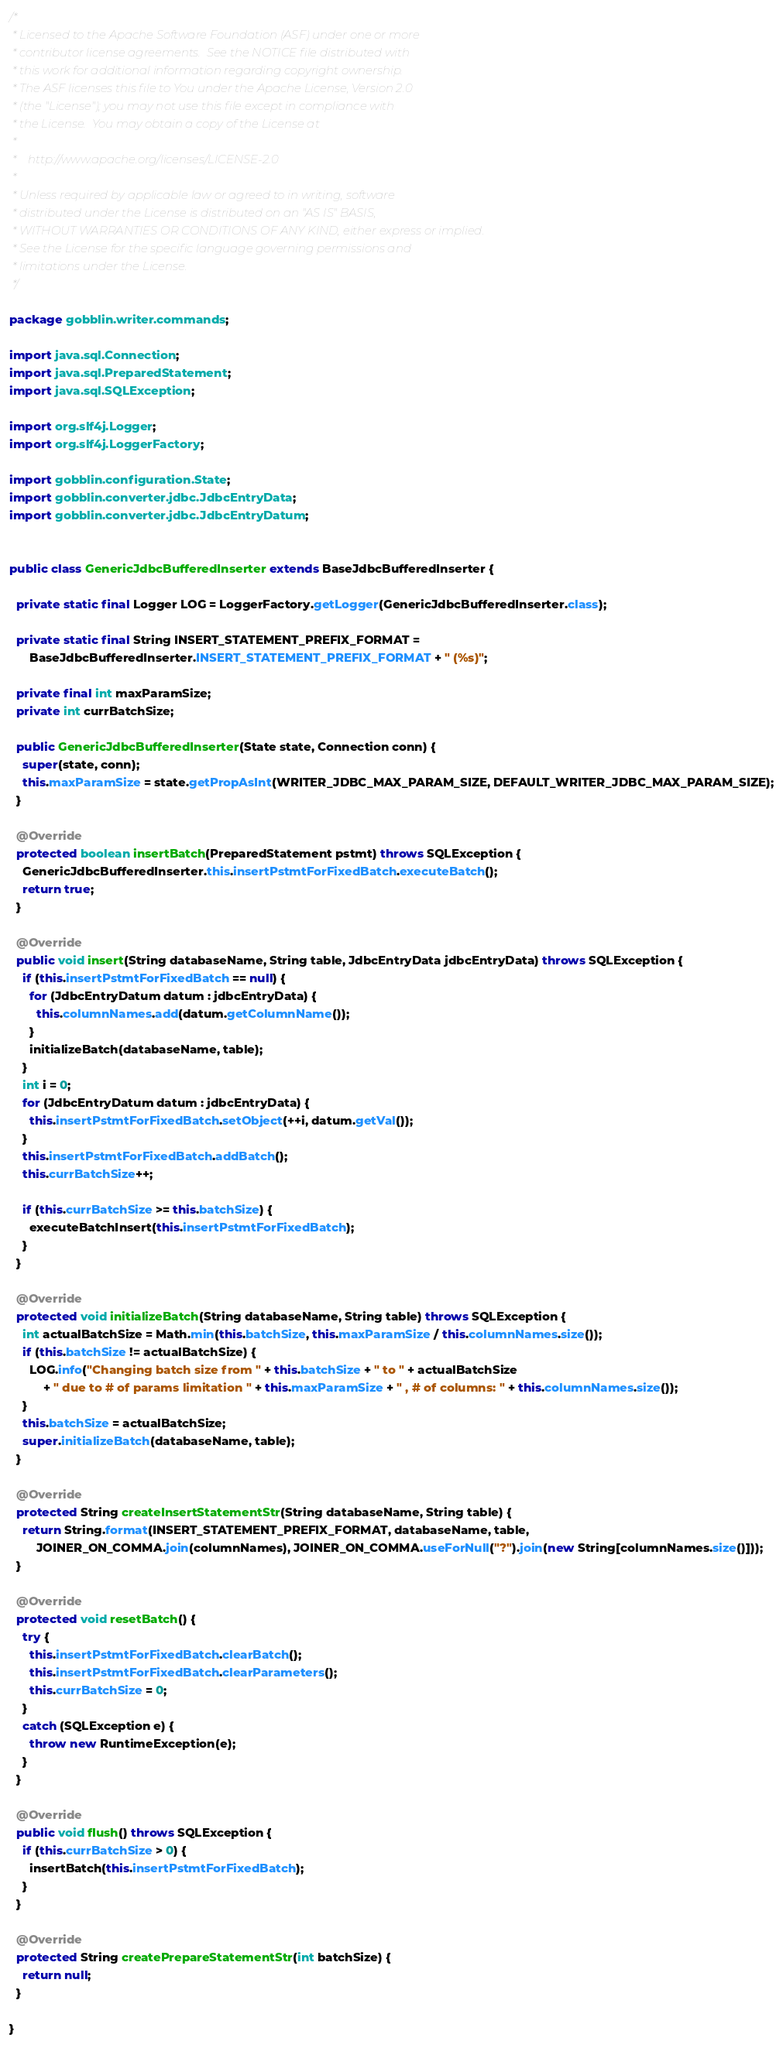Convert code to text. <code><loc_0><loc_0><loc_500><loc_500><_Java_>/*
 * Licensed to the Apache Software Foundation (ASF) under one or more
 * contributor license agreements.  See the NOTICE file distributed with
 * this work for additional information regarding copyright ownership.
 * The ASF licenses this file to You under the Apache License, Version 2.0
 * (the "License"); you may not use this file except in compliance with
 * the License.  You may obtain a copy of the License at
 *
 *    http://www.apache.org/licenses/LICENSE-2.0
 *
 * Unless required by applicable law or agreed to in writing, software
 * distributed under the License is distributed on an "AS IS" BASIS,
 * WITHOUT WARRANTIES OR CONDITIONS OF ANY KIND, either express or implied.
 * See the License for the specific language governing permissions and
 * limitations under the License.
 */

package gobblin.writer.commands;

import java.sql.Connection;
import java.sql.PreparedStatement;
import java.sql.SQLException;

import org.slf4j.Logger;
import org.slf4j.LoggerFactory;

import gobblin.configuration.State;
import gobblin.converter.jdbc.JdbcEntryData;
import gobblin.converter.jdbc.JdbcEntryDatum;


public class GenericJdbcBufferedInserter extends BaseJdbcBufferedInserter {

  private static final Logger LOG = LoggerFactory.getLogger(GenericJdbcBufferedInserter.class);

  private static final String INSERT_STATEMENT_PREFIX_FORMAT =
      BaseJdbcBufferedInserter.INSERT_STATEMENT_PREFIX_FORMAT + " (%s)";

  private final int maxParamSize;
  private int currBatchSize;

  public GenericJdbcBufferedInserter(State state, Connection conn) {
    super(state, conn);
    this.maxParamSize = state.getPropAsInt(WRITER_JDBC_MAX_PARAM_SIZE, DEFAULT_WRITER_JDBC_MAX_PARAM_SIZE);
  }

  @Override
  protected boolean insertBatch(PreparedStatement pstmt) throws SQLException {
    GenericJdbcBufferedInserter.this.insertPstmtForFixedBatch.executeBatch();
    return true;
  }

  @Override
  public void insert(String databaseName, String table, JdbcEntryData jdbcEntryData) throws SQLException {
    if (this.insertPstmtForFixedBatch == null) {
      for (JdbcEntryDatum datum : jdbcEntryData) {
        this.columnNames.add(datum.getColumnName());
      }
      initializeBatch(databaseName, table);
    }
    int i = 0;
    for (JdbcEntryDatum datum : jdbcEntryData) {
      this.insertPstmtForFixedBatch.setObject(++i, datum.getVal());
    }
    this.insertPstmtForFixedBatch.addBatch();
    this.currBatchSize++;

    if (this.currBatchSize >= this.batchSize) {
      executeBatchInsert(this.insertPstmtForFixedBatch);
    }
  }

  @Override
  protected void initializeBatch(String databaseName, String table) throws SQLException {
    int actualBatchSize = Math.min(this.batchSize, this.maxParamSize / this.columnNames.size());
    if (this.batchSize != actualBatchSize) {
      LOG.info("Changing batch size from " + this.batchSize + " to " + actualBatchSize
          + " due to # of params limitation " + this.maxParamSize + " , # of columns: " + this.columnNames.size());
    }
    this.batchSize = actualBatchSize;
    super.initializeBatch(databaseName, table);
  }

  @Override
  protected String createInsertStatementStr(String databaseName, String table) {
    return String.format(INSERT_STATEMENT_PREFIX_FORMAT, databaseName, table,
        JOINER_ON_COMMA.join(columnNames), JOINER_ON_COMMA.useForNull("?").join(new String[columnNames.size()]));
  }

  @Override
  protected void resetBatch() {
    try {
      this.insertPstmtForFixedBatch.clearBatch();
      this.insertPstmtForFixedBatch.clearParameters();
      this.currBatchSize = 0;
    }
    catch (SQLException e) {
      throw new RuntimeException(e);
    }
  }

  @Override
  public void flush() throws SQLException {
    if (this.currBatchSize > 0) {
      insertBatch(this.insertPstmtForFixedBatch);
    }
  }

  @Override
  protected String createPrepareStatementStr(int batchSize) {
    return null;
  }

}</code> 